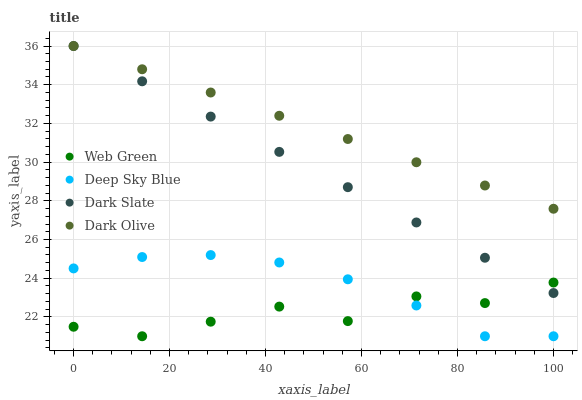Does Web Green have the minimum area under the curve?
Answer yes or no. Yes. Does Dark Olive have the maximum area under the curve?
Answer yes or no. Yes. Does Deep Sky Blue have the minimum area under the curve?
Answer yes or no. No. Does Deep Sky Blue have the maximum area under the curve?
Answer yes or no. No. Is Dark Slate the smoothest?
Answer yes or no. Yes. Is Web Green the roughest?
Answer yes or no. Yes. Is Dark Olive the smoothest?
Answer yes or no. No. Is Dark Olive the roughest?
Answer yes or no. No. Does Deep Sky Blue have the lowest value?
Answer yes or no. Yes. Does Dark Olive have the lowest value?
Answer yes or no. No. Does Dark Olive have the highest value?
Answer yes or no. Yes. Does Deep Sky Blue have the highest value?
Answer yes or no. No. Is Web Green less than Dark Olive?
Answer yes or no. Yes. Is Dark Olive greater than Web Green?
Answer yes or no. Yes. Does Dark Olive intersect Dark Slate?
Answer yes or no. Yes. Is Dark Olive less than Dark Slate?
Answer yes or no. No. Is Dark Olive greater than Dark Slate?
Answer yes or no. No. Does Web Green intersect Dark Olive?
Answer yes or no. No. 